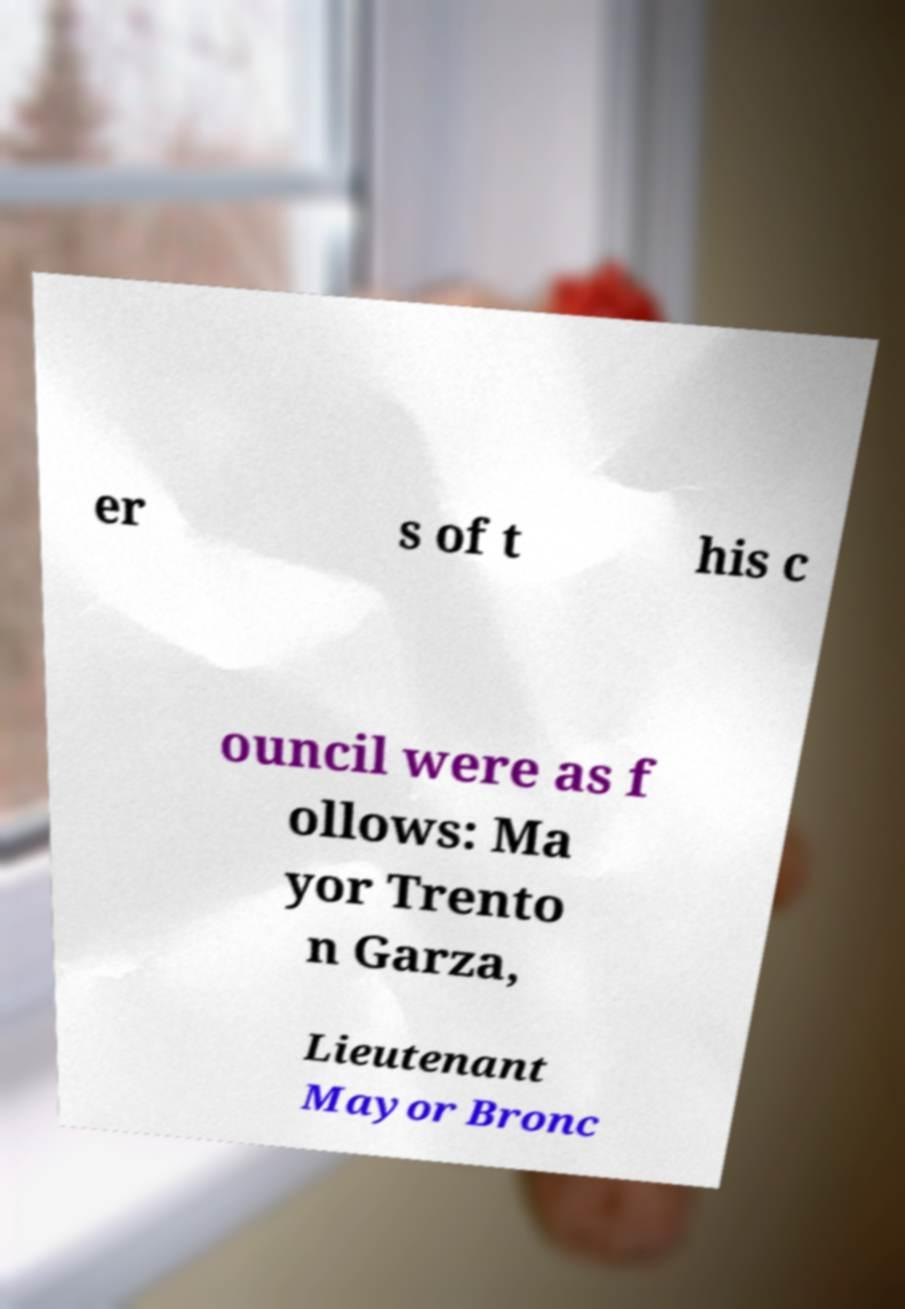Can you read and provide the text displayed in the image?This photo seems to have some interesting text. Can you extract and type it out for me? er s of t his c ouncil were as f ollows: Ma yor Trento n Garza, Lieutenant Mayor Bronc 